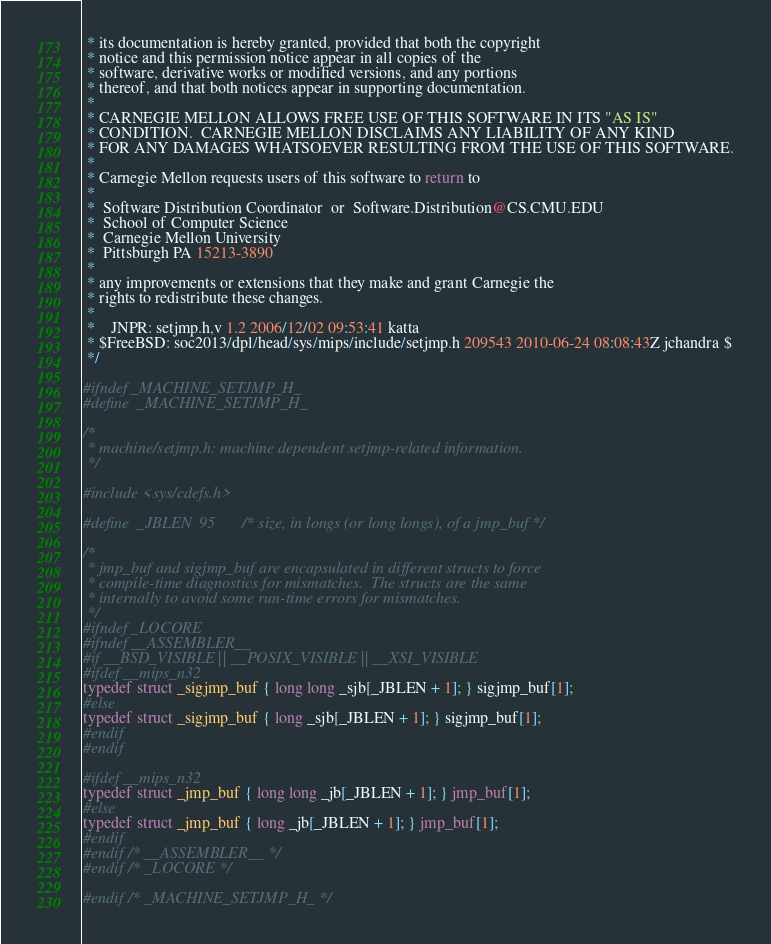Convert code to text. <code><loc_0><loc_0><loc_500><loc_500><_C_> * its documentation is hereby granted, provided that both the copyright
 * notice and this permission notice appear in all copies of the
 * software, derivative works or modified versions, and any portions
 * thereof, and that both notices appear in supporting documentation.
 *
 * CARNEGIE MELLON ALLOWS FREE USE OF THIS SOFTWARE IN ITS "AS IS"
 * CONDITION.  CARNEGIE MELLON DISCLAIMS ANY LIABILITY OF ANY KIND
 * FOR ANY DAMAGES WHATSOEVER RESULTING FROM THE USE OF THIS SOFTWARE.
 *
 * Carnegie Mellon requests users of this software to return to
 *
 *  Software Distribution Coordinator  or  Software.Distribution@CS.CMU.EDU
 *  School of Computer Science
 *  Carnegie Mellon University
 *  Pittsburgh PA 15213-3890
 *
 * any improvements or extensions that they make and grant Carnegie the
 * rights to redistribute these changes.
 *
 *	JNPR: setjmp.h,v 1.2 2006/12/02 09:53:41 katta
 * $FreeBSD: soc2013/dpl/head/sys/mips/include/setjmp.h 209543 2010-06-24 08:08:43Z jchandra $
 */

#ifndef _MACHINE_SETJMP_H_
#define	_MACHINE_SETJMP_H_

/*
 * machine/setjmp.h: machine dependent setjmp-related information.
 */

#include <sys/cdefs.h>

#define	_JBLEN	95		/* size, in longs (or long longs), of a jmp_buf */

/*
 * jmp_buf and sigjmp_buf are encapsulated in different structs to force
 * compile-time diagnostics for mismatches.  The structs are the same
 * internally to avoid some run-time errors for mismatches.
 */
#ifndef _LOCORE
#ifndef __ASSEMBLER__
#if __BSD_VISIBLE || __POSIX_VISIBLE || __XSI_VISIBLE
#ifdef __mips_n32
typedef struct _sigjmp_buf { long long _sjb[_JBLEN + 1]; } sigjmp_buf[1];
#else
typedef struct _sigjmp_buf { long _sjb[_JBLEN + 1]; } sigjmp_buf[1];
#endif
#endif

#ifdef __mips_n32
typedef struct _jmp_buf { long long _jb[_JBLEN + 1]; } jmp_buf[1];
#else
typedef struct _jmp_buf { long _jb[_JBLEN + 1]; } jmp_buf[1];
#endif
#endif /* __ASSEMBLER__ */
#endif /* _LOCORE */

#endif /* _MACHINE_SETJMP_H_ */
</code> 